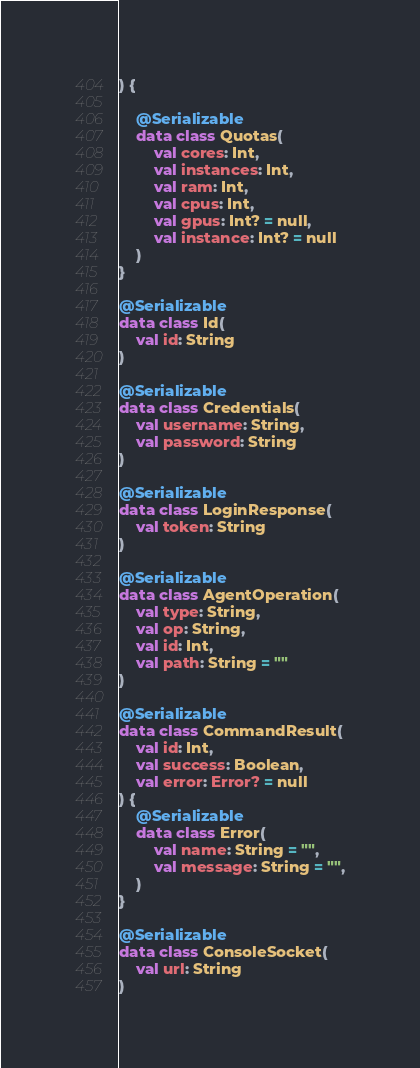<code> <loc_0><loc_0><loc_500><loc_500><_Kotlin_>) {

    @Serializable
    data class Quotas(
        val cores: Int,
        val instances: Int,
        val ram: Int,
        val cpus: Int,
        val gpus: Int? = null,
        val instance: Int? = null
    )
}

@Serializable
data class Id(
    val id: String
)

@Serializable
data class Credentials(
    val username: String,
    val password: String
)

@Serializable
data class LoginResponse(
    val token: String
)

@Serializable
data class AgentOperation(
    val type: String,
    val op: String,
    val id: Int,
    val path: String = ""
)

@Serializable
data class CommandResult(
    val id: Int,
    val success: Boolean,
    val error: Error? = null
) {
    @Serializable
    data class Error(
        val name: String = "",
        val message: String = "",
    )
}

@Serializable
data class ConsoleSocket(
    val url: String
)
</code> 